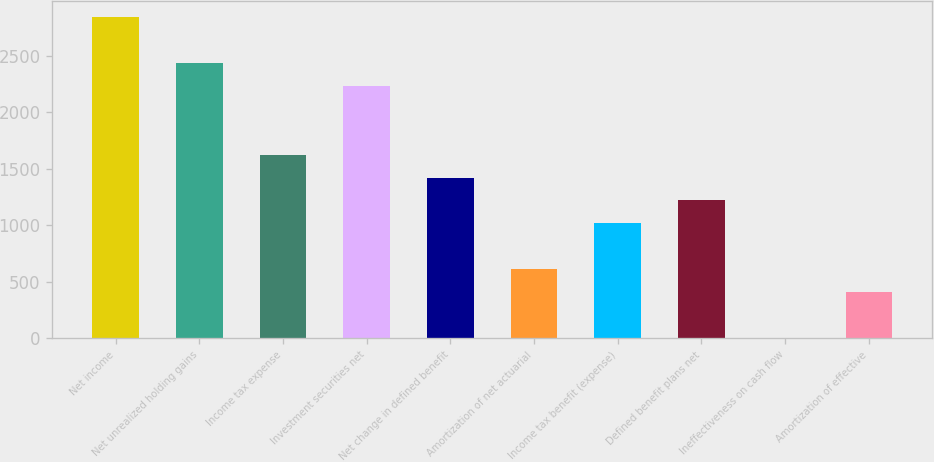Convert chart to OTSL. <chart><loc_0><loc_0><loc_500><loc_500><bar_chart><fcel>Net income<fcel>Net unrealized holding gains<fcel>Income tax expense<fcel>Investment securities net<fcel>Net change in defined benefit<fcel>Amortization of net actuarial<fcel>Income tax benefit (expense)<fcel>Defined benefit plans net<fcel>Ineffectiveness on cash flow<fcel>Amortization of effective<nl><fcel>2842.1<fcel>2436.1<fcel>1624.1<fcel>2233.1<fcel>1421.1<fcel>609.1<fcel>1015.1<fcel>1218.1<fcel>0.1<fcel>406.1<nl></chart> 